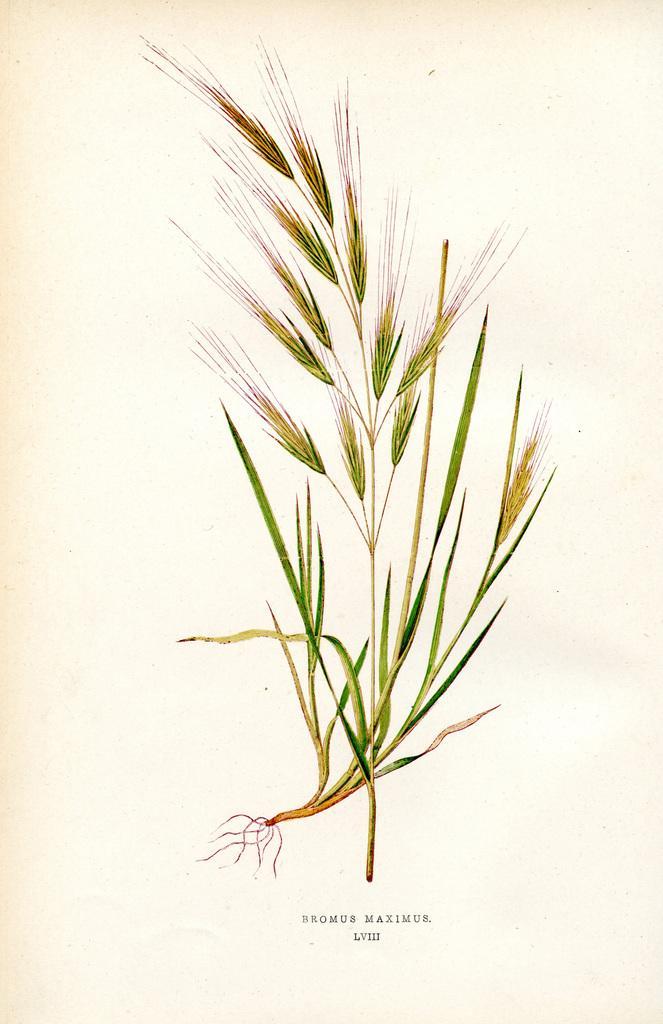Describe this image in one or two sentences. In the image we can see a page. On it there is a diagram of grass and we can see the text. 